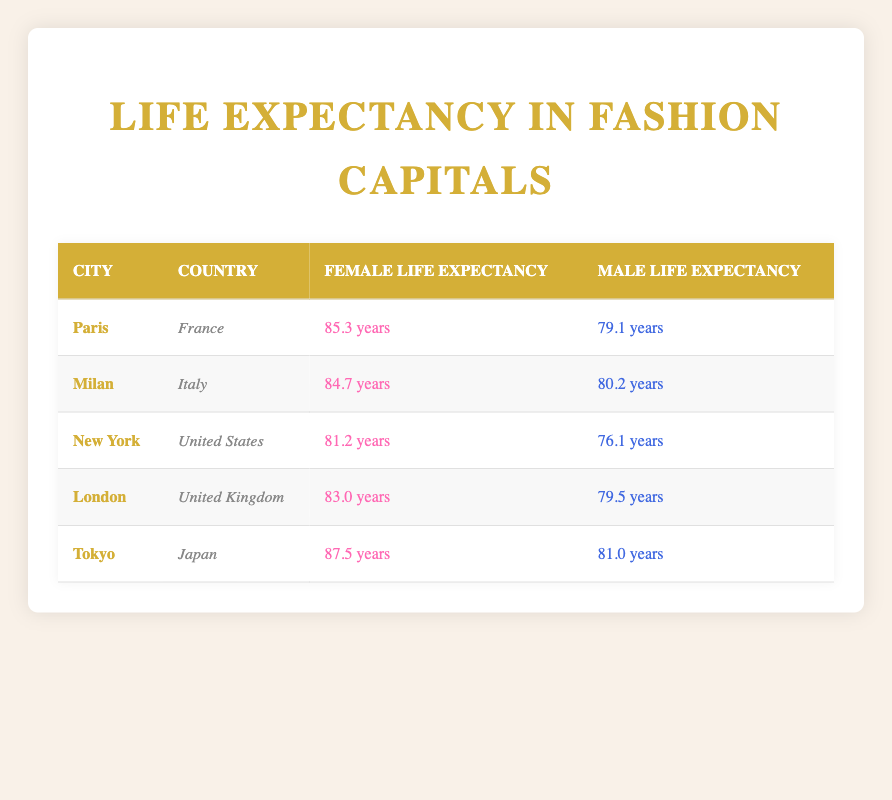What is the female life expectancy in Paris? Referring to the row for Paris, the female life expectancy is listed as 85.3 years.
Answer: 85.3 years Which city has the highest male life expectancy? By comparing the male life expectancy values for each city: Paris (79.1), Milan (80.2), New York (76.1), London (79.5), and Tokyo (81.0), Tokyo has the highest male life expectancy at 81.0 years.
Answer: Tokyo What is the difference in female life expectancy between Tokyo and New York? The female life expectancy in Tokyo is 87.5 years, and in New York, it is 81.2 years. The difference is calculated as 87.5 - 81.2 = 6.3 years.
Answer: 6.3 years Is the male life expectancy in Milan greater than that in New York? The male life expectancy in Milan is 80.2 years while in New York it is 76.1 years. Since 80.2 is greater than 76.1, the answer is yes.
Answer: Yes What is the average female life expectancy across all the cities listed? Adding up all the female life expectancies: 85.3 (Paris) + 84.7 (Milan) + 81.2 (New York) + 83.0 (London) + 87.5 (Tokyo) = 421.7. There are 5 cities, so the average is 421.7 / 5 = 84.34 years.
Answer: 84.34 years Which city has the lowest female life expectancy and what is that value? Looking at the female life expectancy values: Paris (85.3), Milan (84.7), New York (81.2), London (83.0), and Tokyo (87.5), New York has the lowest value at 81.2 years.
Answer: New York, 81.2 years In which city is the female life expectancy greater than 84 years? The cities with female life expectancy above 84 years are Paris (85.3), Milan (84.7), and Tokyo (87.5). After checking each city’s value, all these cities exceed 84 years.
Answer: Paris, Milan, Tokyo What is the total life expectancy for females in London and Tokyo combined? Adding the female life expectancy of London (83.0 years) and Tokyo (87.5 years) gives 83.0 + 87.5 = 170.5 years.
Answer: 170.5 years 